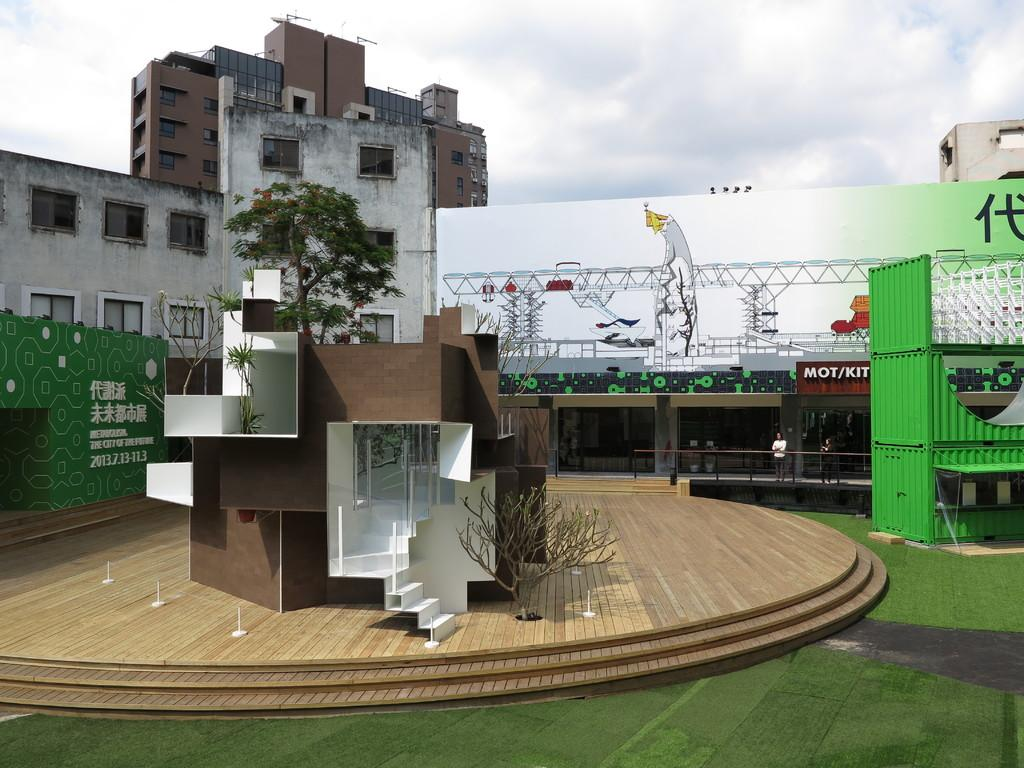What type of structures can be seen in the image? There are buildings, a house, and a lighting truss in the image. Are there any people present in the image? Yes, there are persons in the image. What type of vegetation is visible in the image? There are trees in the image. What architectural feature can be seen in the house? There is a staircase in the house. What can be seen through the windows in the image? The windows in the image provide a view of the surrounding environment, including trees and possibly other buildings. What is visible in the background of the image? The sky is visible in the background of the image. What type of fuel is being used by the committee in the image? There is no committee or fuel present in the image. What language are the persons in the image speaking? The image does not provide any information about the language being spoken by the persons in the image. 